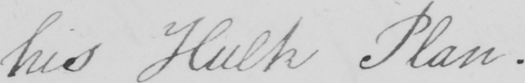Can you tell me what this handwritten text says? his Hulk Plan . 